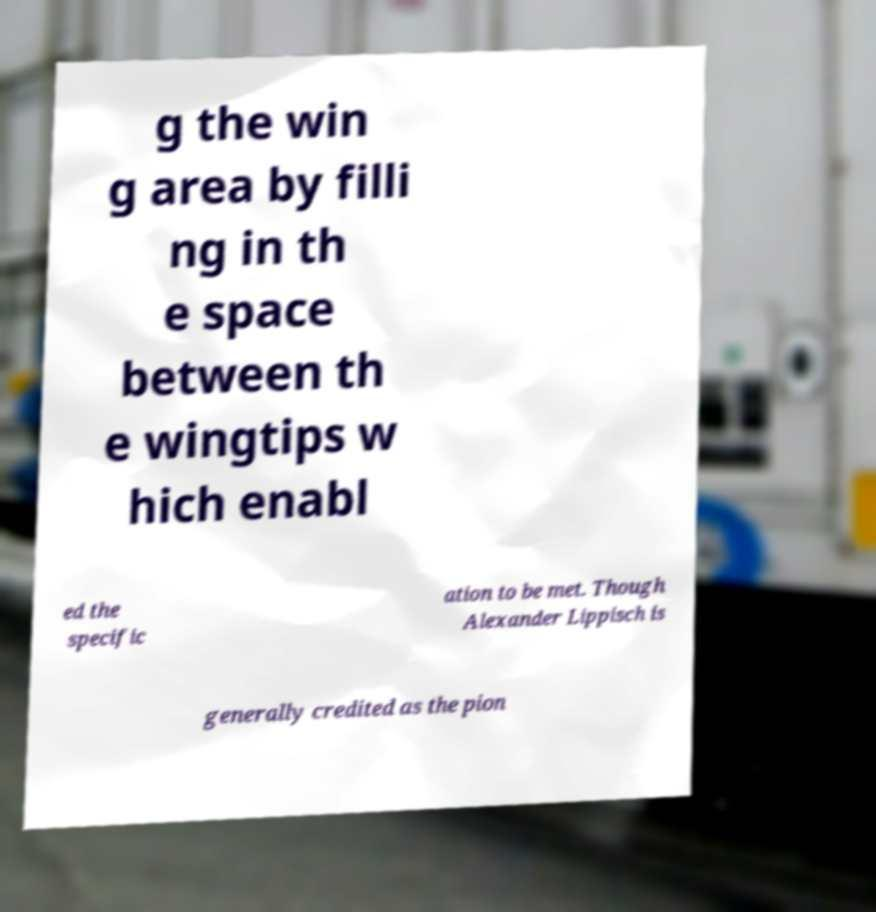I need the written content from this picture converted into text. Can you do that? g the win g area by filli ng in th e space between th e wingtips w hich enabl ed the specific ation to be met. Though Alexander Lippisch is generally credited as the pion 